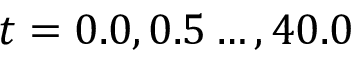Convert formula to latex. <formula><loc_0><loc_0><loc_500><loc_500>t = 0 . 0 , 0 . 5 \dots , 4 0 . 0</formula> 